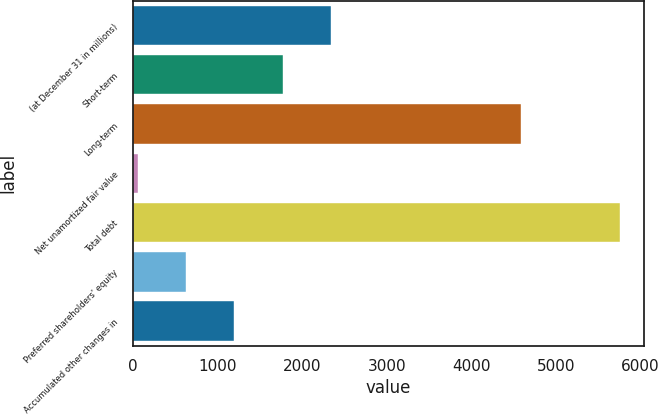Convert chart to OTSL. <chart><loc_0><loc_0><loc_500><loc_500><bar_chart><fcel>(at December 31 in millions)<fcel>Short-term<fcel>Long-term<fcel>Net unamortized fair value<fcel>Total debt<fcel>Preferred shareholders' equity<fcel>Accumulated other changes in<nl><fcel>2338.8<fcel>1768.6<fcel>4588<fcel>58<fcel>5760<fcel>628.2<fcel>1198.4<nl></chart> 